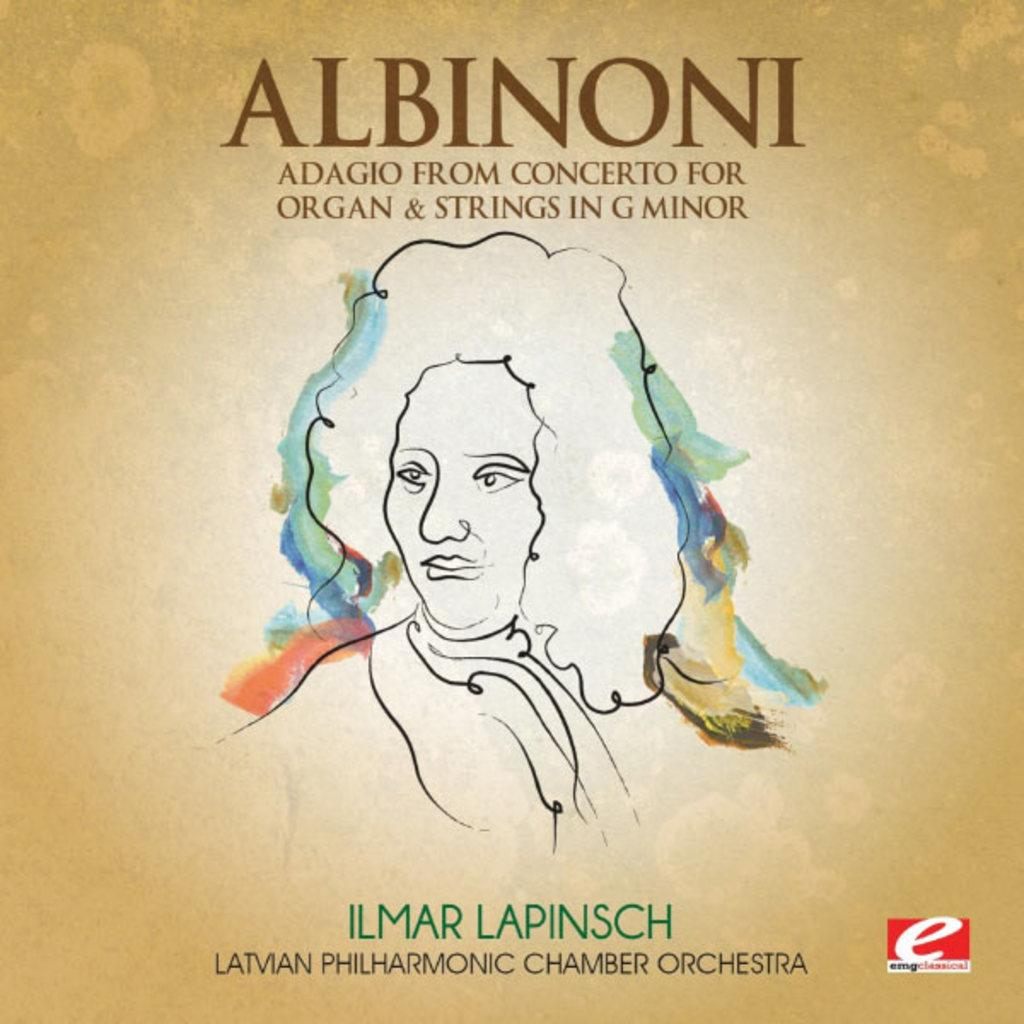What is featured on the poster in the image? The poster contains a picture of a person. What else can be seen on the poster besides the image? There is text written on the poster. What color are the borders of the poster? The borders of the poster are white in color. Can you hear the whistle in the image? There is no whistle present in the image; it is a visual representation of a poster. What type of mountain is visible in the image? There is no mountain present in the image; it features a poster with a picture of a person. 